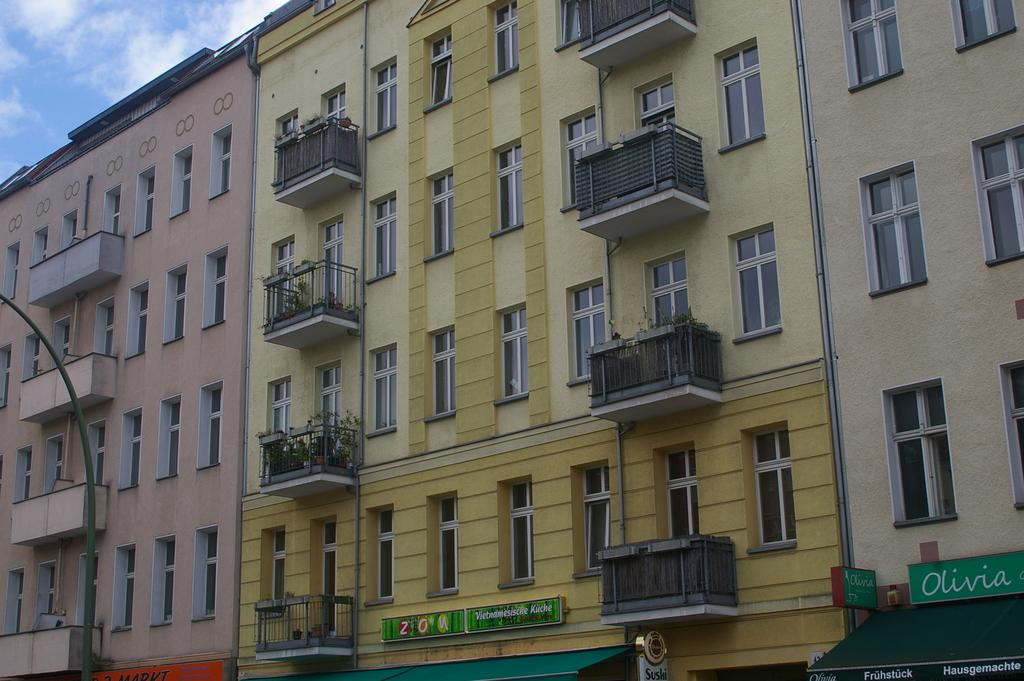What type of structures are visible in the image? There are buildings in the image. Where are the plant pots located in relation to the buildings? The plant pots are on a balcony of a building. What can be seen in the background of the image? The background of the image includes the sky. What type of straw is being used by the quince in the image? There is no straw or quince present in the image. 